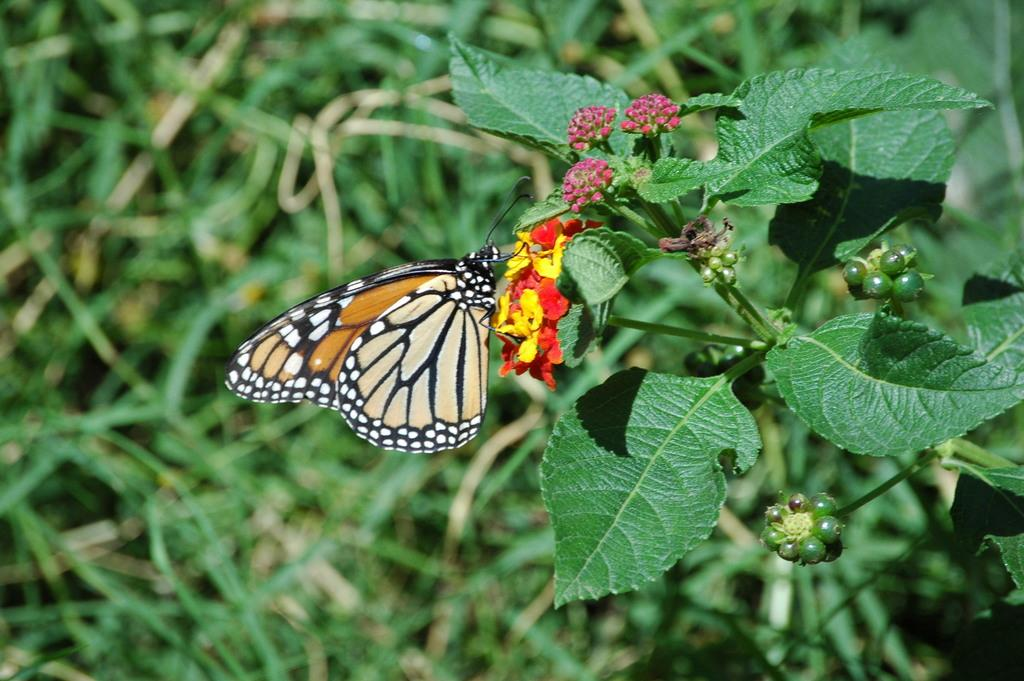What type of vegetation can be seen in the image? There are leaves in the image. What animal is present in the image? There is a butterfly in the image. Where is the butterfly located in the image? The butterfly is on flowers. Can you describe the background of the image? The background of the image is blurred. What type of mitten is the butterfly using to hold the toothpaste in the image? There is no mitten or toothpaste present in the image; it features a butterfly on flowers with a blurred background. How does the butterfly touch the flowers in the image? The butterfly is likely touching the flowers with its legs and proboscis, but the image does not show the exact point of contact. 